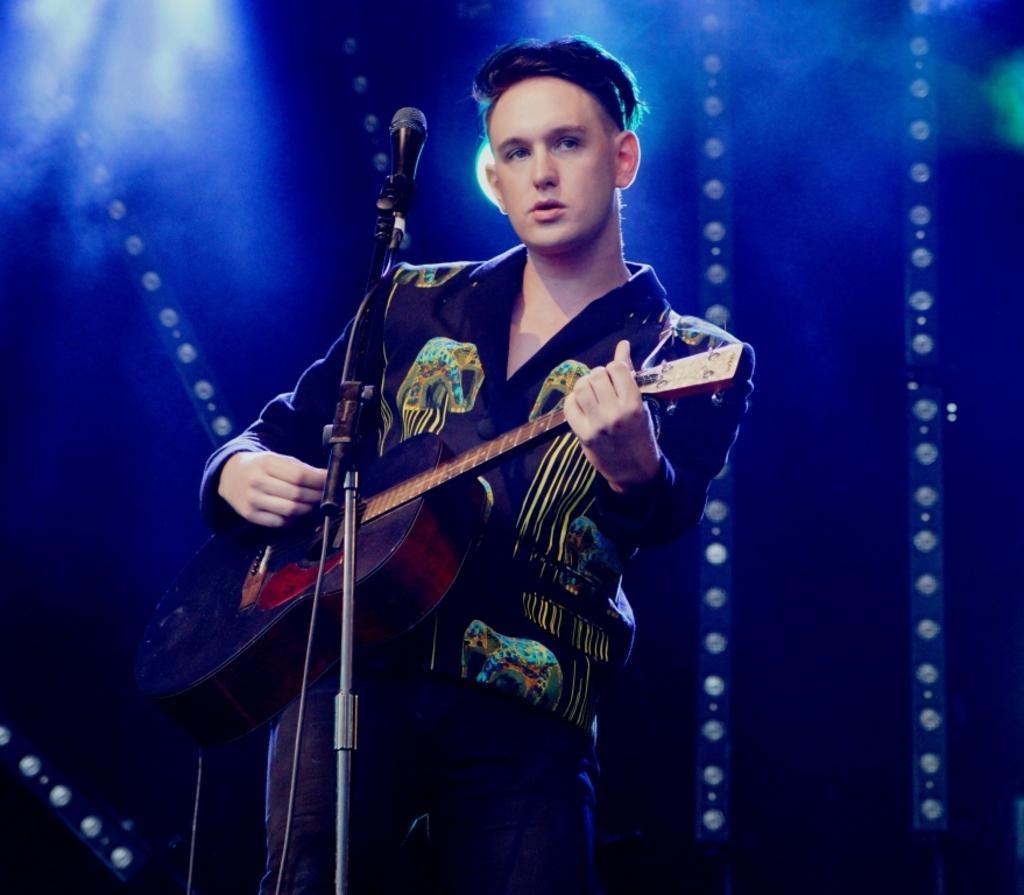Who is the main subject in the image? There is a man in the image. What is the man doing in the image? The man is standing and playing a guitar. What object is present in the image that is typically used for amplifying sound? There is a microphone in the image. How many crowns can be seen on the man's head in the image? There are no crowns visible on the man's head in the image. What is the amount of money the man is holding in the image? The image does not show the man holding any money. 